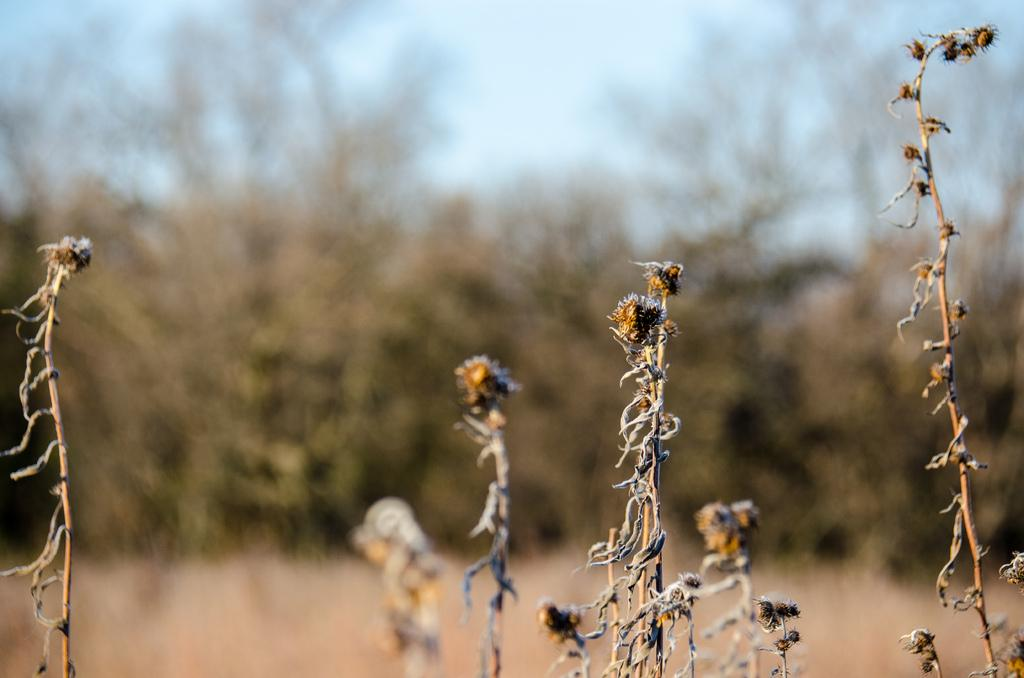What type of plants are in the image? There are dry plants in the image. What other types of vegetation can be seen in the image? There are trees in the image. What is visible in the background of the image? The sky is visible in the image. How much honey is dripping from the men's fingers in the image? There are no men or honey present in the image; it features dry plants and trees. 